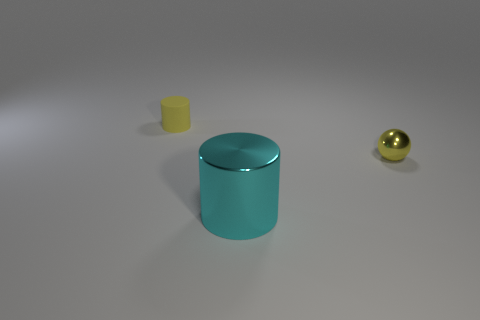Add 3 yellow matte cylinders. How many objects exist? 6 Subtract all cylinders. How many objects are left? 1 Subtract all green spheres. Subtract all big metallic cylinders. How many objects are left? 2 Add 1 tiny yellow shiny spheres. How many tiny yellow shiny spheres are left? 2 Add 3 tiny cylinders. How many tiny cylinders exist? 4 Subtract 0 brown spheres. How many objects are left? 3 